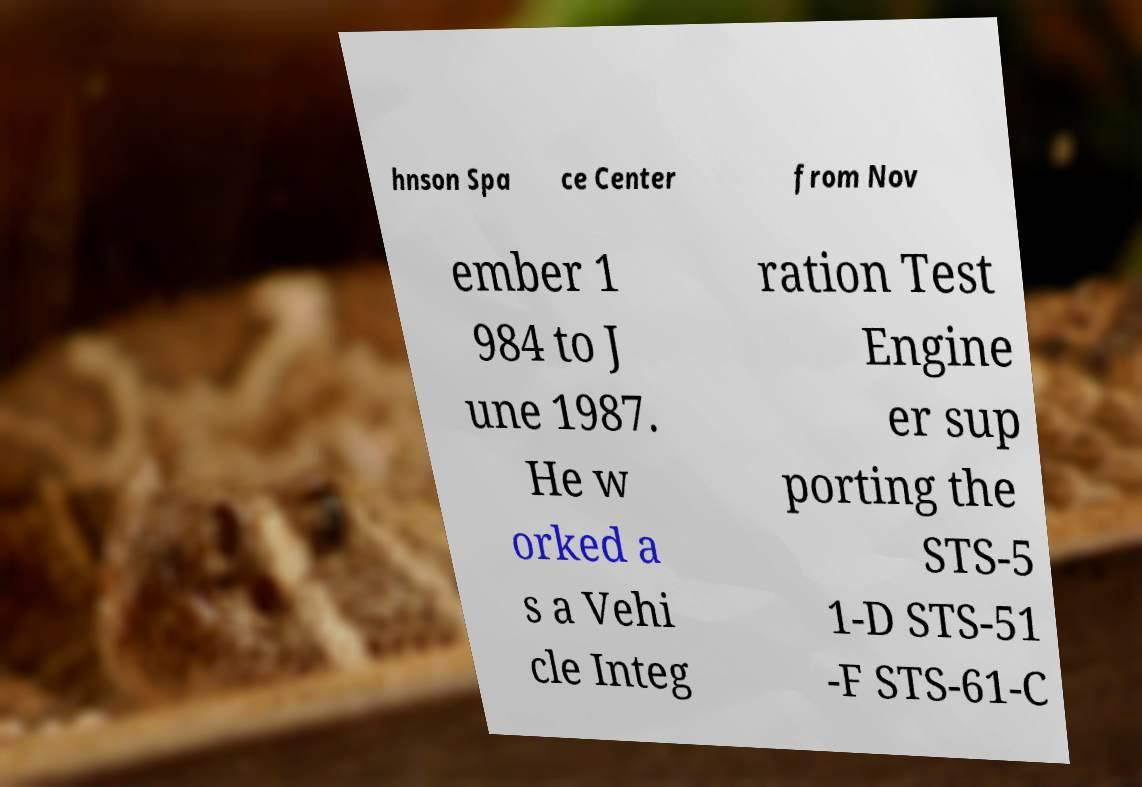Could you assist in decoding the text presented in this image and type it out clearly? hnson Spa ce Center from Nov ember 1 984 to J une 1987. He w orked a s a Vehi cle Integ ration Test Engine er sup porting the STS-5 1-D STS-51 -F STS-61-C 